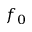<formula> <loc_0><loc_0><loc_500><loc_500>f _ { 0 }</formula> 